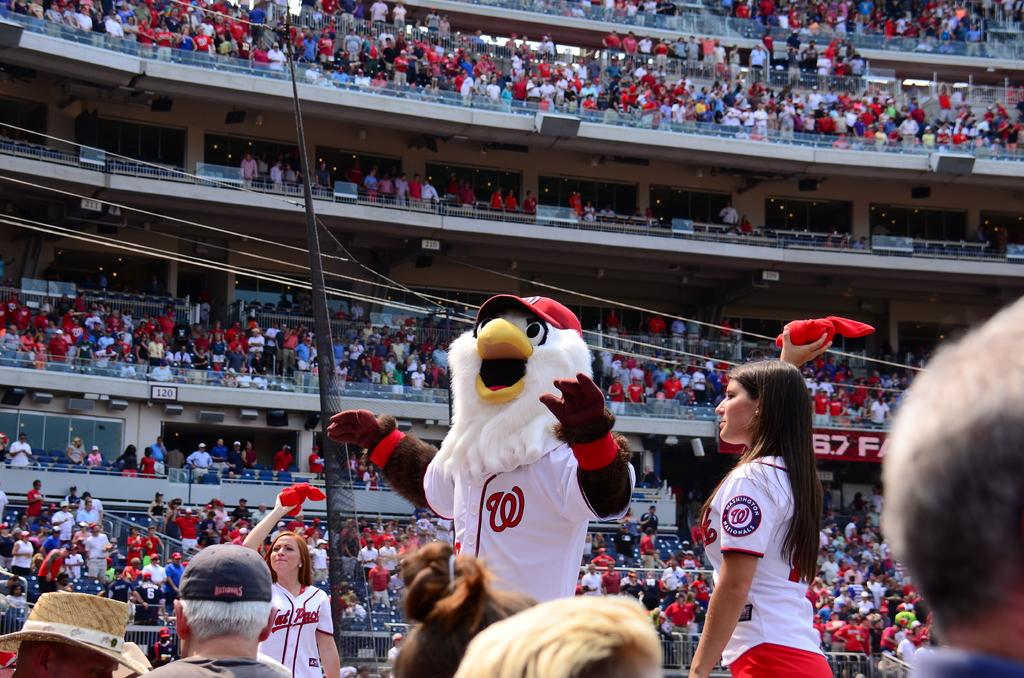Provide a one-sentence caption for the provided image. The mascot for the Nationals pumping the crowd up at a game. 